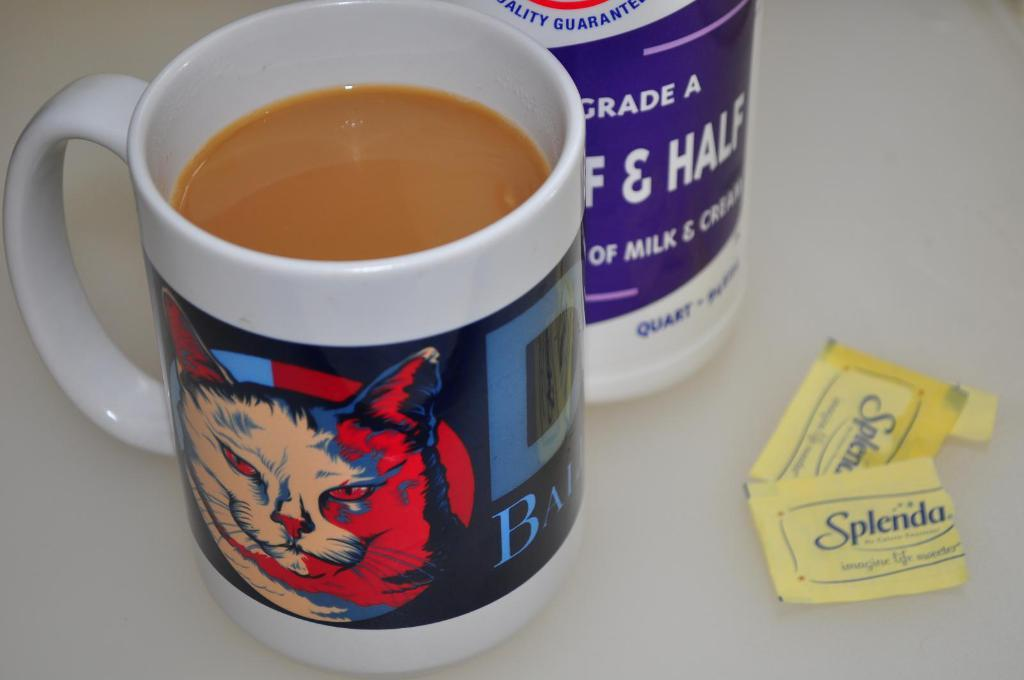<image>
Describe the image concisely. A coffee mug filled with coffee is near some half and half and some packets of Splenda. 